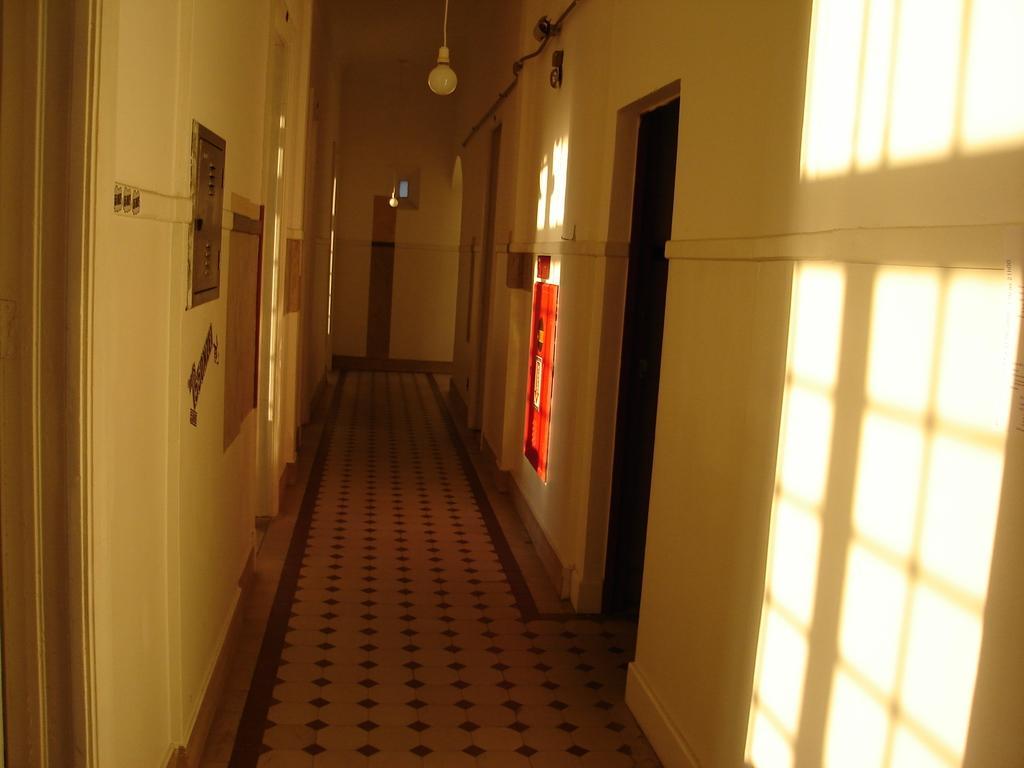Could you give a brief overview of what you see in this image? In this image we can see few lights hanging from the roof, there we can see a few wires, few doors, a cc camera and the shadow of the windows. 